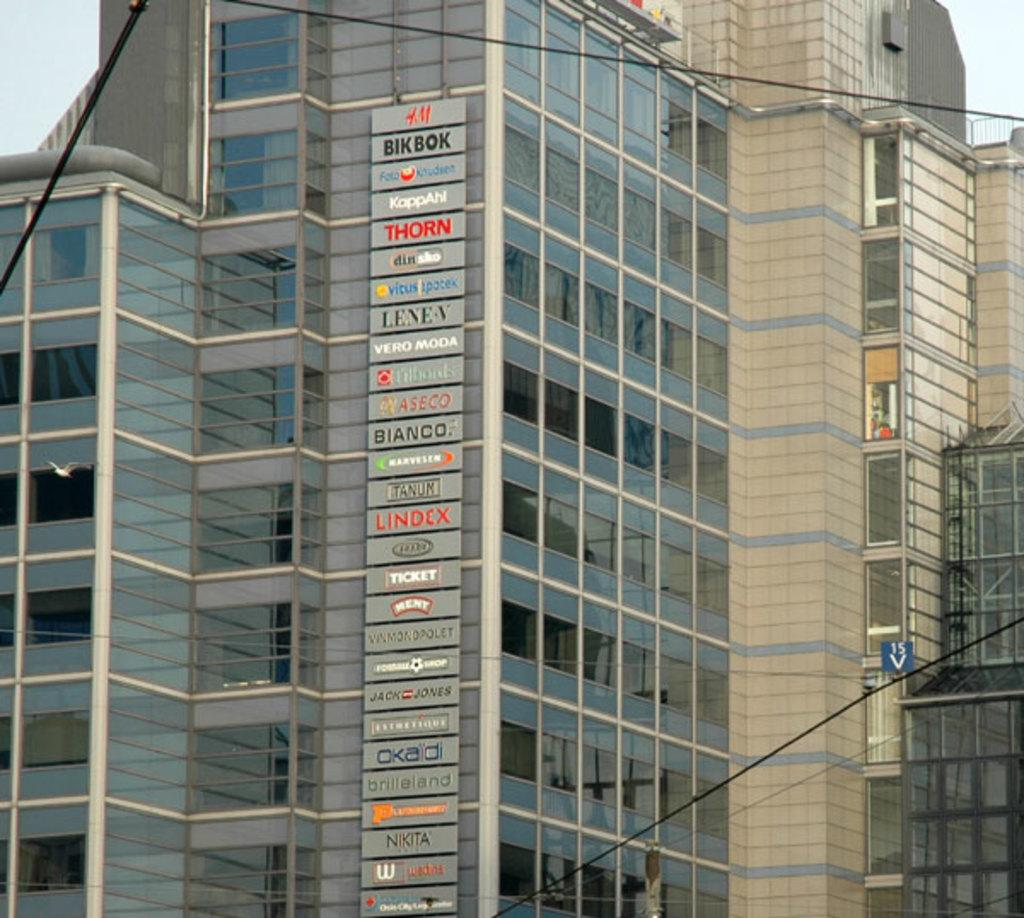What is the main focus of the image? The main focus of the image is the buildings in the center. What is placed in front of the buildings? There are banners with text in front of the buildings. What type of wheel can be seen on the plate in the image? There is no wheel or plate present in the image. 